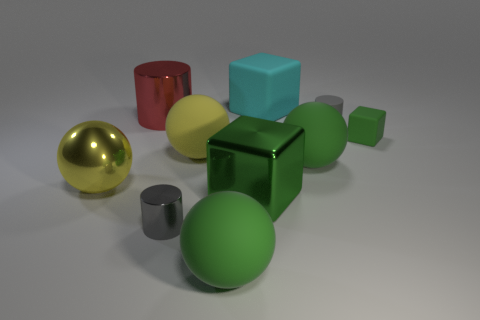Subtract 1 balls. How many balls are left? 3 Subtract all gray balls. Subtract all cyan cylinders. How many balls are left? 4 Subtract all cubes. How many objects are left? 7 Add 1 big cyan shiny cylinders. How many big cyan shiny cylinders exist? 1 Subtract 1 cyan cubes. How many objects are left? 9 Subtract all metal things. Subtract all red cylinders. How many objects are left? 5 Add 3 small rubber things. How many small rubber things are left? 5 